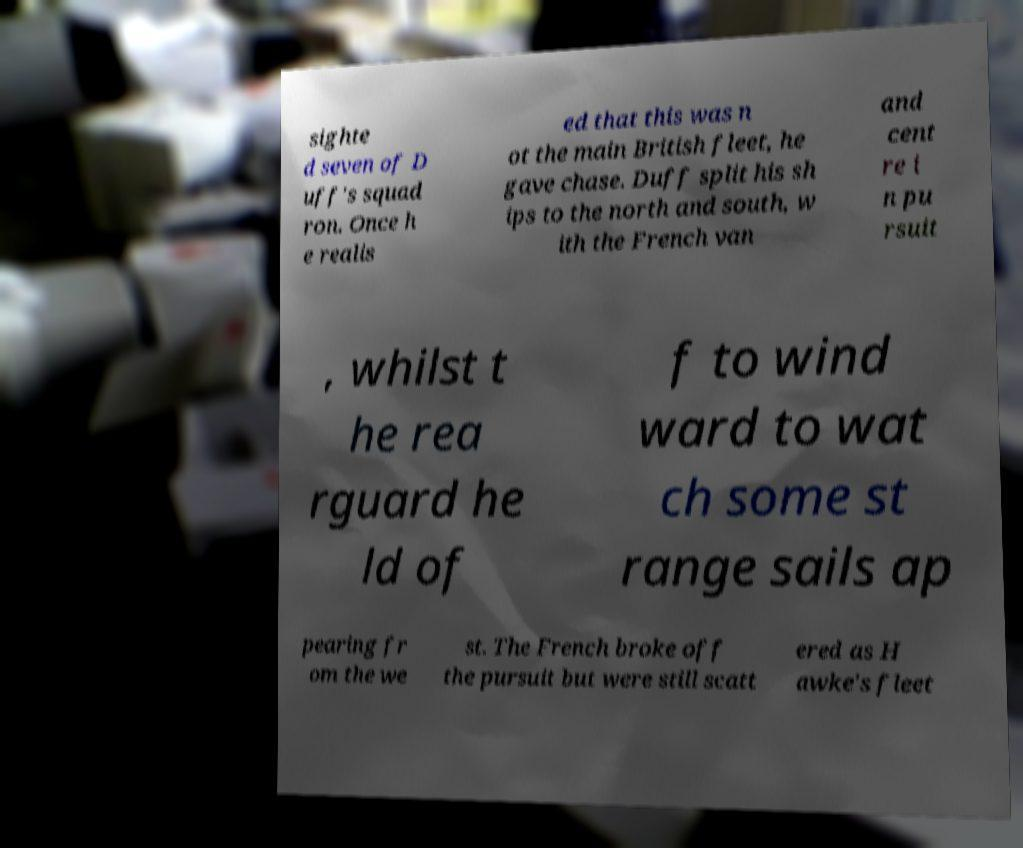Can you read and provide the text displayed in the image?This photo seems to have some interesting text. Can you extract and type it out for me? sighte d seven of D uff's squad ron. Once h e realis ed that this was n ot the main British fleet, he gave chase. Duff split his sh ips to the north and south, w ith the French van and cent re i n pu rsuit , whilst t he rea rguard he ld of f to wind ward to wat ch some st range sails ap pearing fr om the we st. The French broke off the pursuit but were still scatt ered as H awke's fleet 